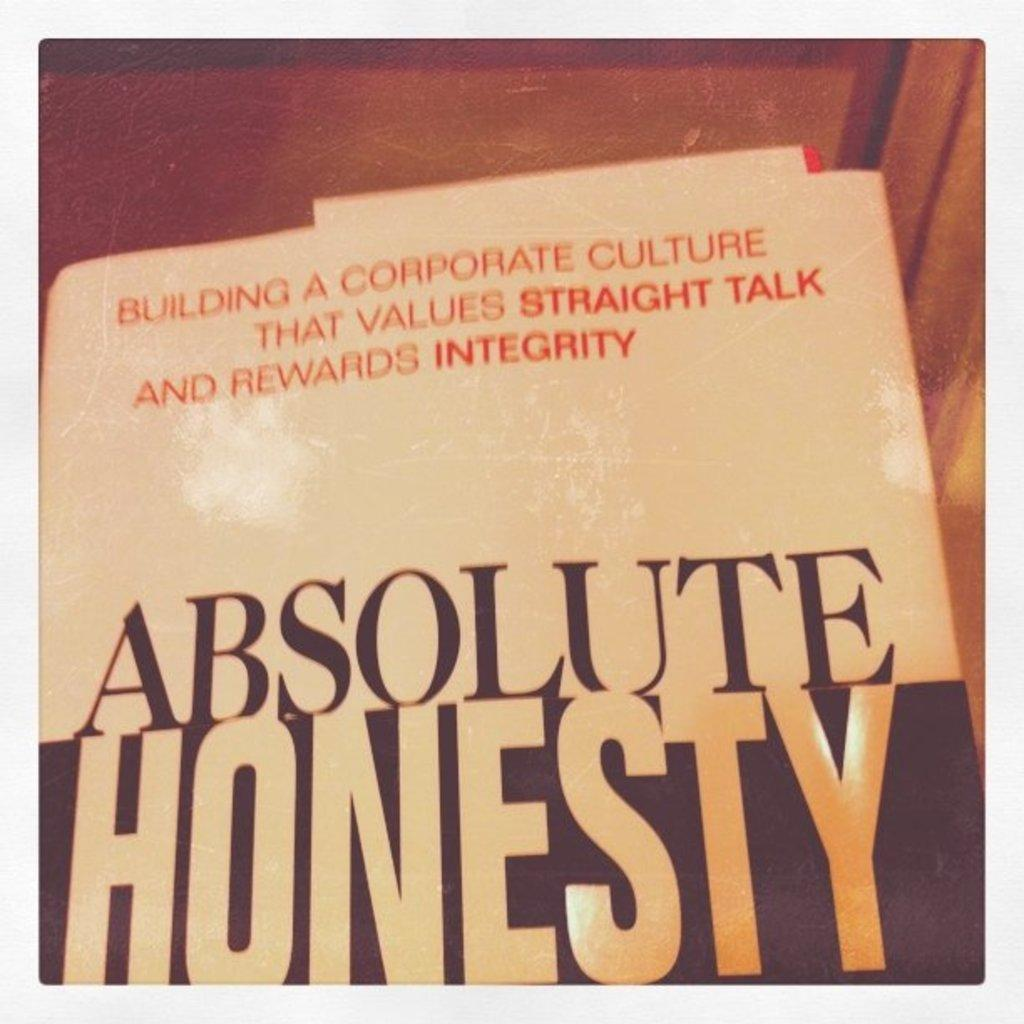<image>
Create a compact narrative representing the image presented. the word honesty is on a book about integrity 